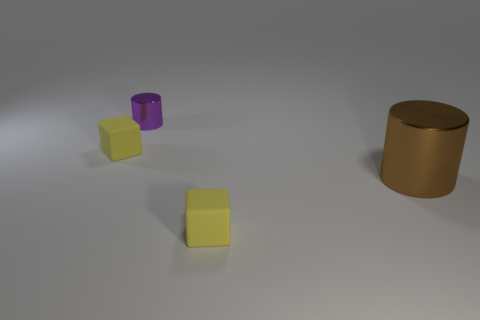Is there anything else that has the same size as the brown cylinder?
Keep it short and to the point. No. How many blocks have the same size as the brown metal cylinder?
Offer a very short reply. 0. Do the tiny shiny object and the big cylinder have the same color?
Offer a terse response. No. Does the block in front of the large brown metal cylinder have the same material as the small cylinder that is left of the big brown cylinder?
Your response must be concise. No. Is the number of cubes greater than the number of gray matte spheres?
Ensure brevity in your answer.  Yes. Are there any other things that are the same color as the small metal cylinder?
Ensure brevity in your answer.  No. Are the large cylinder and the purple cylinder made of the same material?
Offer a very short reply. Yes. Is the number of cyan rubber cylinders less than the number of purple cylinders?
Make the answer very short. Yes. Do the large metallic thing and the small purple metallic thing have the same shape?
Provide a succinct answer. Yes. The big thing is what color?
Your response must be concise. Brown. 